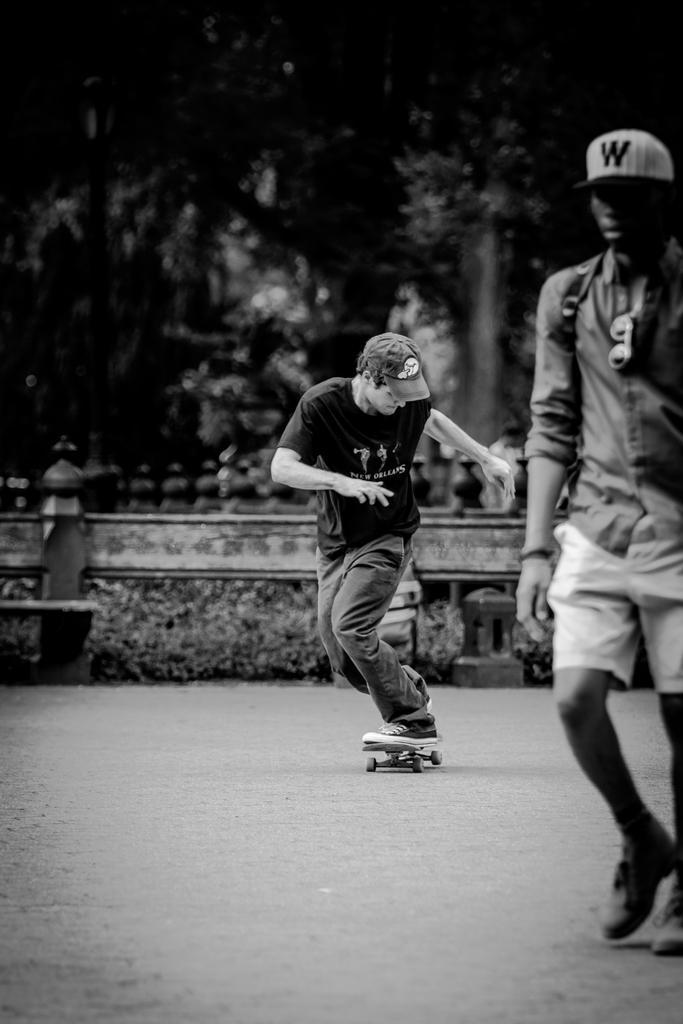In one or two sentences, can you explain what this image depicts? As we can see in the image on the right side there is a person walking. The person in the middle is skating. There are plates, wall and trees. The image is little dark. 